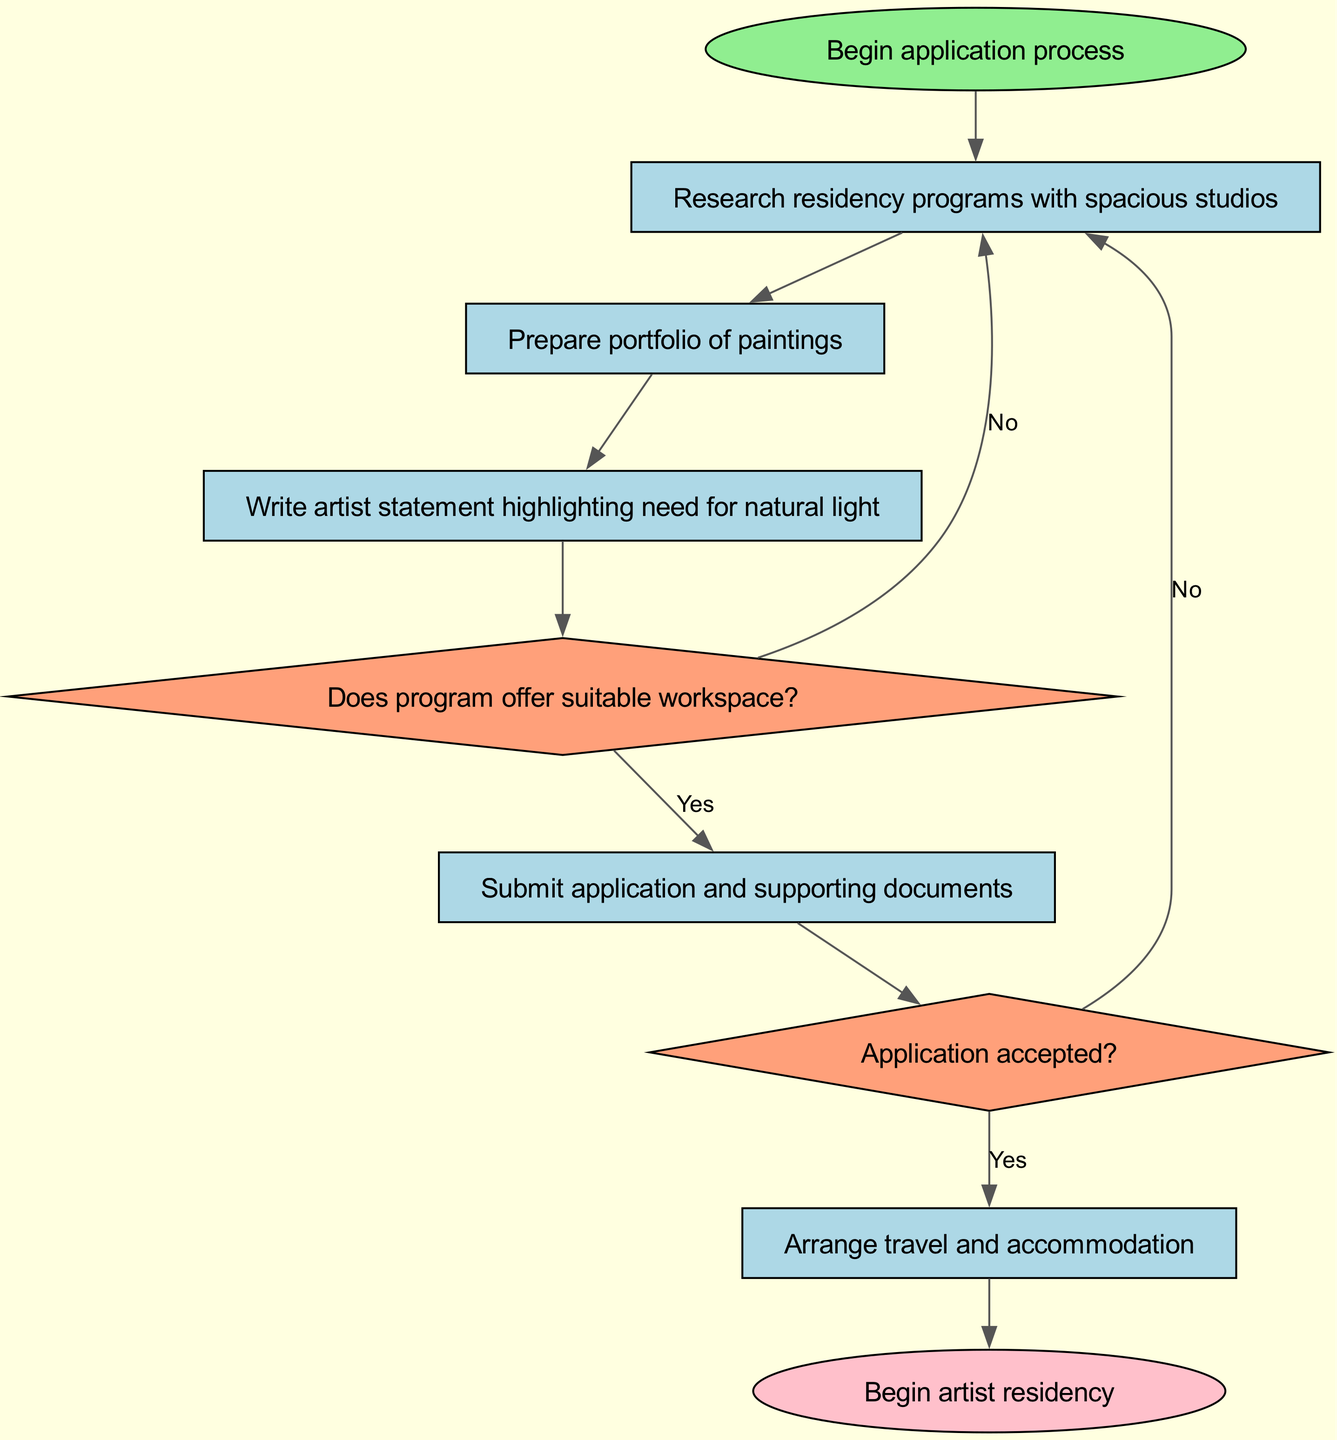What is the first step in the application process? The diagram indicates that the application process begins with the node labeled "Begin application process." This is the starting point that leads to subsequent actions.
Answer: Begin application process How many decision nodes are present in the diagram? Upon examining the diagram, there are two decision nodes labeled "Does program offer suitable workspace?" and "Application accepted?" These nodes require a yes/no response to determine the next step in the process.
Answer: 2 What action follows after writing the artist statement? The diagram shows that after writing the artist statement, the next action is to ask, "Does program offer suitable workspace?" This indicates that the writing is followed by a decision point.
Answer: Does program offer suitable workspace? If the program does not offer suitable workspace, what should the applicant do next? According to the diagram, if the answer to the decision "Does program offer suitable workspace?" is "No," the applicant is directed back to "Research residency programs with spacious studios." This means they need to look for other options.
Answer: Research residency programs with spacious studios What happens after the application is accepted? The flowchart indicates that once the application is accepted, the next step is to "Arrange travel and accommodation." This shows the progression from application status to logistical preparations.
Answer: Arrange travel and accommodation 